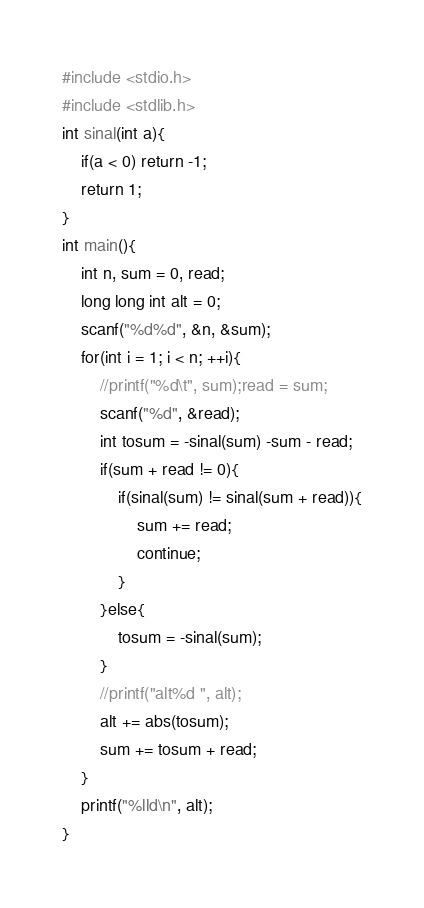Convert code to text. <code><loc_0><loc_0><loc_500><loc_500><_C_>#include <stdio.h>
#include <stdlib.h>
int sinal(int a){
	if(a < 0) return -1;
	return 1;
}
int main(){
	int n, sum = 0, read;
	long long int alt = 0;
	scanf("%d%d", &n, &sum);
	for(int i = 1; i < n; ++i){
		//printf("%d\t", sum);read = sum;
		scanf("%d", &read);
		int tosum = -sinal(sum) -sum - read;
		if(sum + read != 0){
			if(sinal(sum) != sinal(sum + read)){
				sum += read;
				continue;
			}
		}else{
			tosum = -sinal(sum);
		}
		//printf("alt%d ", alt);
		alt += abs(tosum);
		sum += tosum + read;
	}
	printf("%lld\n", alt);
}</code> 